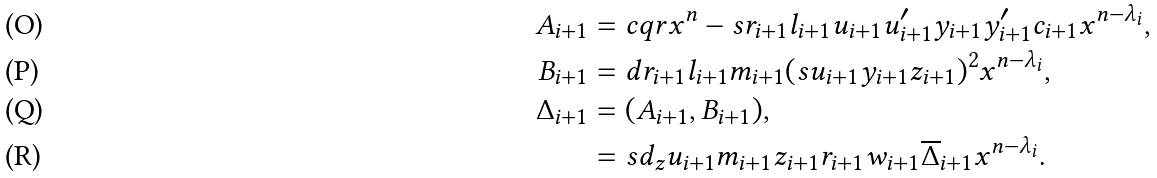<formula> <loc_0><loc_0><loc_500><loc_500>A _ { i + 1 } & = c q r x ^ { n } - s r _ { i + 1 } l _ { i + 1 } u _ { i + 1 } u _ { i + 1 } ^ { \prime } y _ { i + 1 } y _ { i + 1 } ^ { \prime } c _ { i + 1 } x ^ { n - \lambda _ { i } } , \\ B _ { i + 1 } & = d r _ { i + 1 } l _ { i + 1 } m _ { i + 1 } ( s u _ { i + 1 } y _ { i + 1 } z _ { i + 1 } ) ^ { 2 } x ^ { n - \lambda _ { i } } , \\ \Delta _ { i + 1 } & = ( A _ { i + 1 } , B _ { i + 1 } ) , \\ & = s d _ { z } u _ { i + 1 } m _ { i + 1 } z _ { i + 1 } r _ { i + 1 } w _ { i + 1 } \overline { \Delta } _ { i + 1 } x ^ { n - \lambda _ { i } } .</formula> 